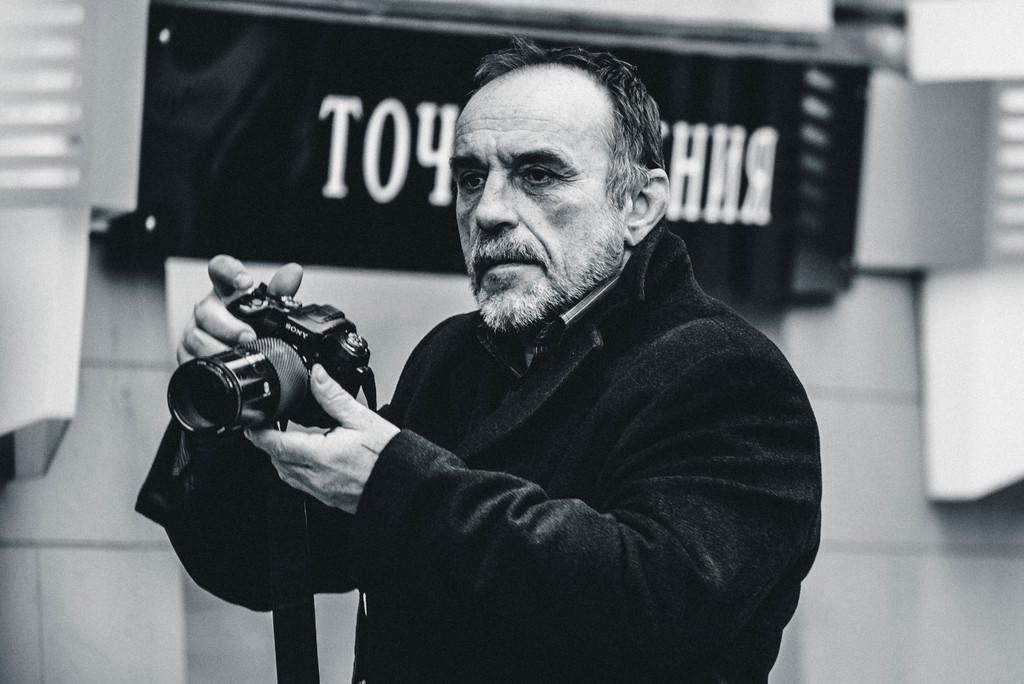What is the person in the image doing? The person is standing in the image and holding a camera in their hand. What is the person wearing in the image? The person is wearing a black jacket in the image. What can be seen in the background of the image? There is a hoarding board in the background, and text is written on it. What type of house is visible in the image? There is no house visible in the image; it only features a person, a camera, and a hoarding board in the background. What is the current temperature in the image? The image does not provide any information about the temperature; it only shows a person, a camera, and a hoarding board in the background. 